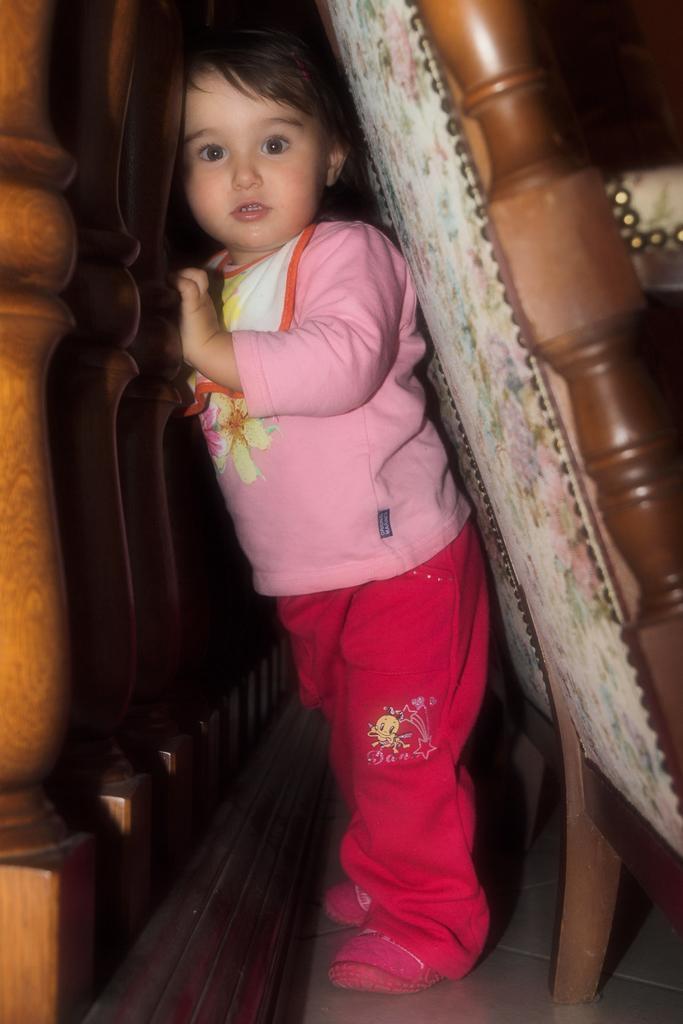Could you give a brief overview of what you see in this image? In this image there is a baby visible in front of wooden fence, on the right side there are two chairs visible. 